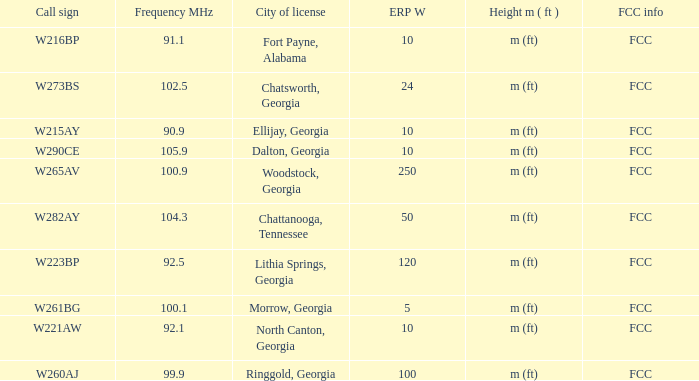Which City of license has a Frequency MHz smaller than 100.9, and a ERP W larger than 100? Lithia Springs, Georgia. 